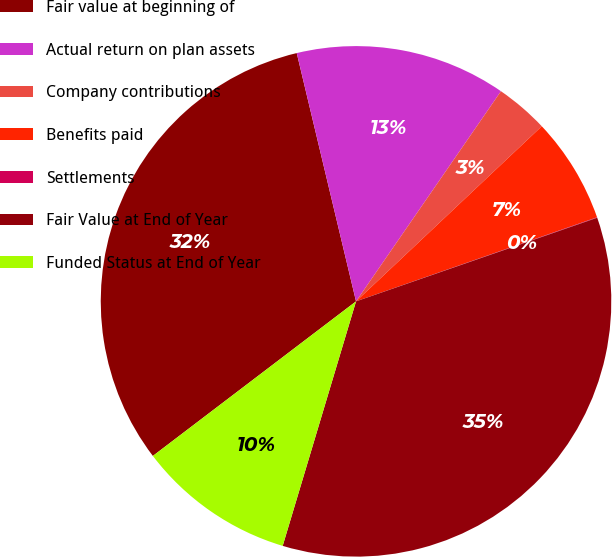Convert chart. <chart><loc_0><loc_0><loc_500><loc_500><pie_chart><fcel>Fair value at beginning of<fcel>Actual return on plan assets<fcel>Company contributions<fcel>Benefits paid<fcel>Settlements<fcel>Fair Value at End of Year<fcel>Funded Status at End of Year<nl><fcel>31.62%<fcel>13.34%<fcel>3.36%<fcel>6.69%<fcel>0.03%<fcel>34.95%<fcel>10.01%<nl></chart> 